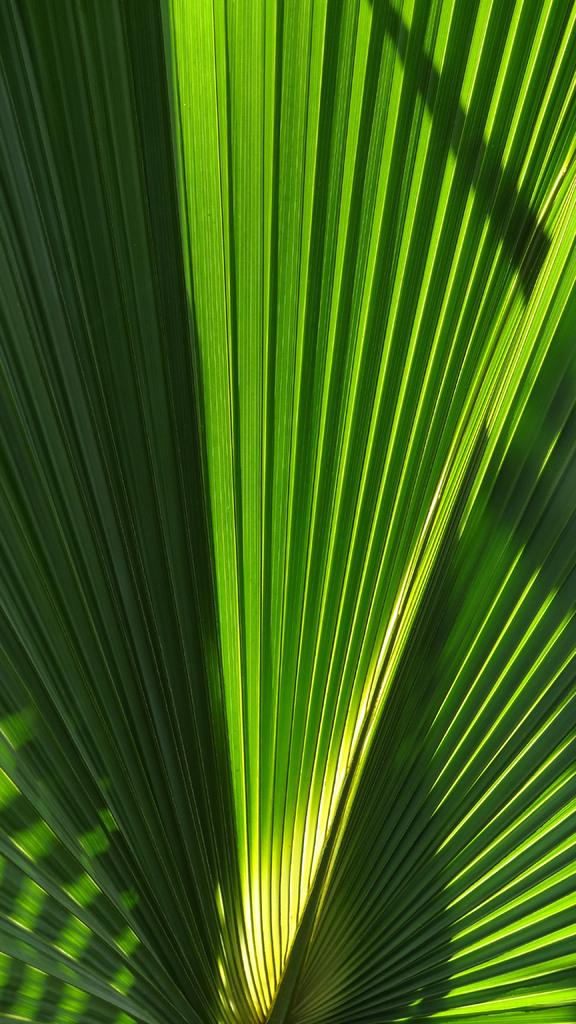What type of plant material is visible in the image? There is a green leaf in the image. What type of pipe is being played in the image? There is no pipe present in the image; it only features a green leaf. What act is being performed by the leaf in the image? Leaves are not capable of performing acts, as they are inanimate plant parts. 